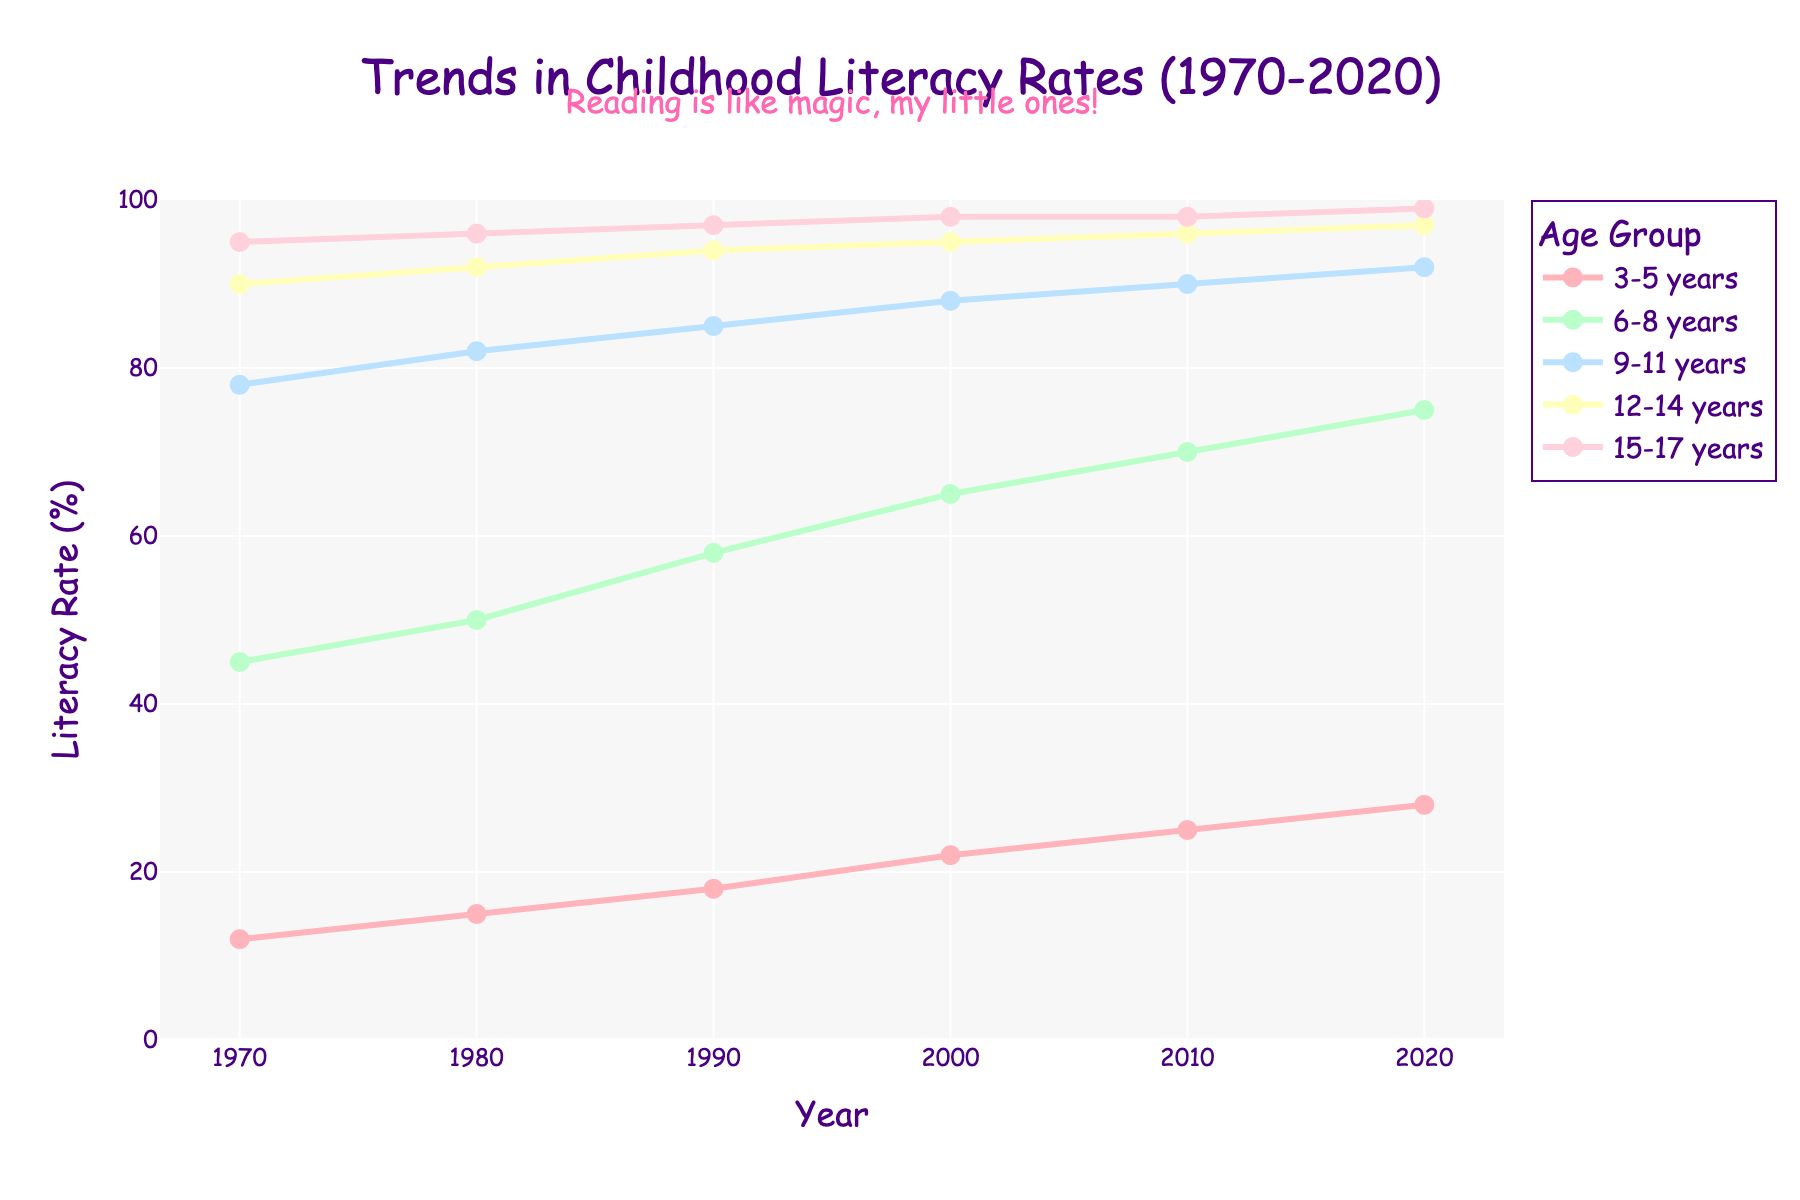What age group showed the largest increase in literacy rate from 1970 to 2020? First, find the increase for each age group by subtracting the 1970 value from the 2020 value: (3-5 years: 28-12=16, 6-8 years: 75-45=30, 9-11 years: 92-78=14, 12-14 years: 97-90=7, 15-17 years: 99-95=4). The largest increase is for the 6-8 years group.
Answer: 6-8 years Which age group had the highest literacy rate in the year 1980? Look at the data for each age group in the year 1980 and pick the highest value: (3-5 years: 15, 6-8 years: 50, 9-11 years: 82, 12-14 years: 92, 15-17 years: 96). The highest value is 96 for the 15-17 years group.
Answer: 15-17 years Which two age groups remained the closest in literacy rates across all years displayed? Visually inspect the lines and note which two remain closest across all years. The 12-14 and 15-17 years groups are almost parallel and very close to each other throughout the entire period.
Answer: 12-14 years and 15-17 years By how many percentage points did the literacy rate for the 3-5 years age group increase between 1990 and 2020? Subtract the literacy rate value for the 3-5 years age group in 1990 from the value in 2020 (28 - 18 = 10).
Answer: 10 What was the average literacy rate for the 9-11 years group across all decades shown in the chart? Sum the literacy rates for the 9-11 years group across all decades (78 + 82 + 85 + 88 + 90 + 92 = 515) and then divide by the number of decades (515 / 6 = approx. 85.83).
Answer: 85.83 Which age group saw the smallest change in literacy rate from 2000 to 2020? Calculate the difference in literacy rates for each age group between 2000 and 2020: (3-5 years: 28-22=6, 6-8 years: 75-65=10, 9-11 years: 92-88=4, 12-14 years: 97-95=2, 15-17 years: 99-98=1). The smallest change is for the 15-17 years group.
Answer: 15-17 years Which age group had a literacy rate closest to the overall average rate in the year 2020? First, calculate the overall average literacy rate for 2020 by summing the rates and dividing by the number of age groups: (28+75+92+97+99)/5=78.2. The closest value to this average is 75 for the 6-8 years group.
Answer: 6-8 years 